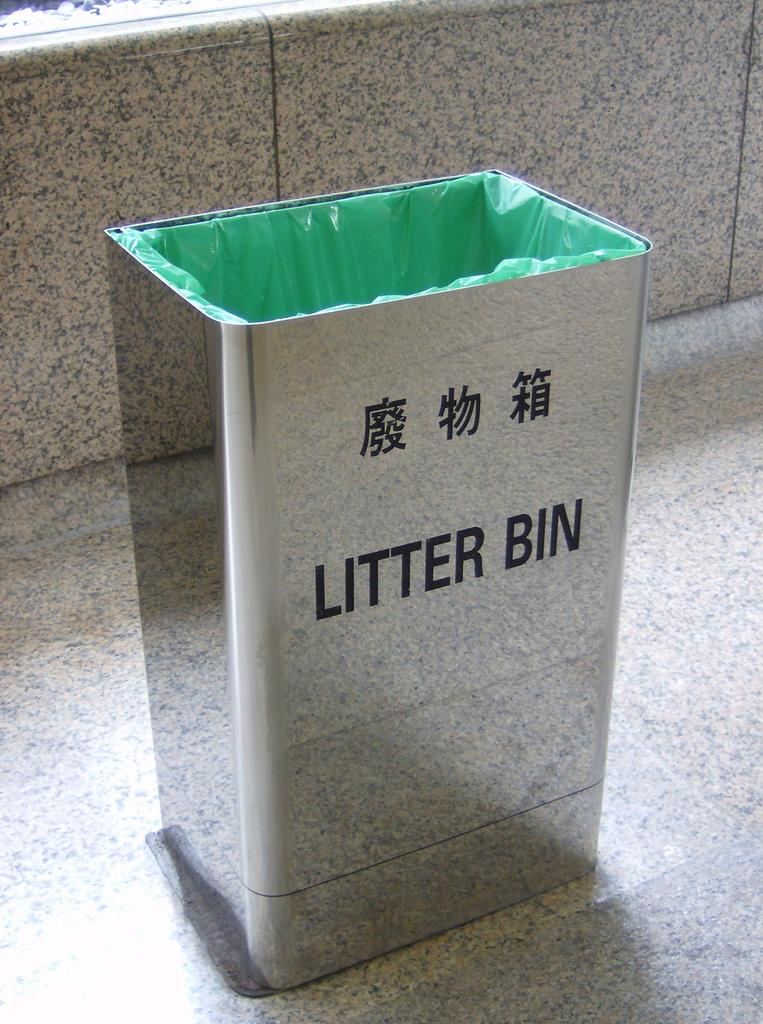Provide a one-sentence caption for the provided image. The sliver trash can also has a foreign writing on it. 